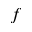<formula> <loc_0><loc_0><loc_500><loc_500>f</formula> 